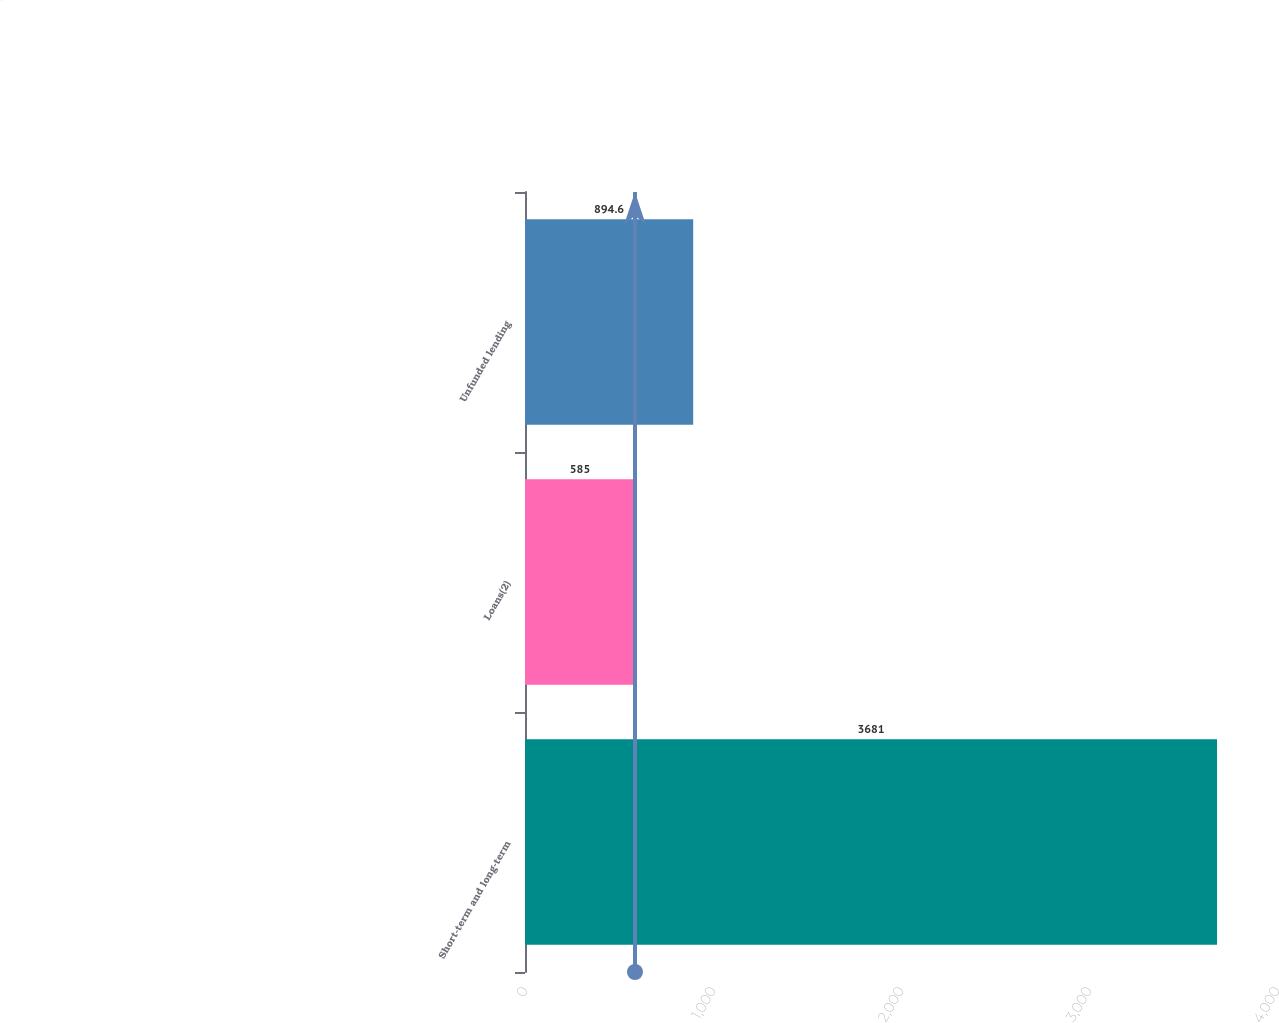Convert chart to OTSL. <chart><loc_0><loc_0><loc_500><loc_500><bar_chart><fcel>Short-term and long-term<fcel>Loans(2)<fcel>Unfunded lending<nl><fcel>3681<fcel>585<fcel>894.6<nl></chart> 